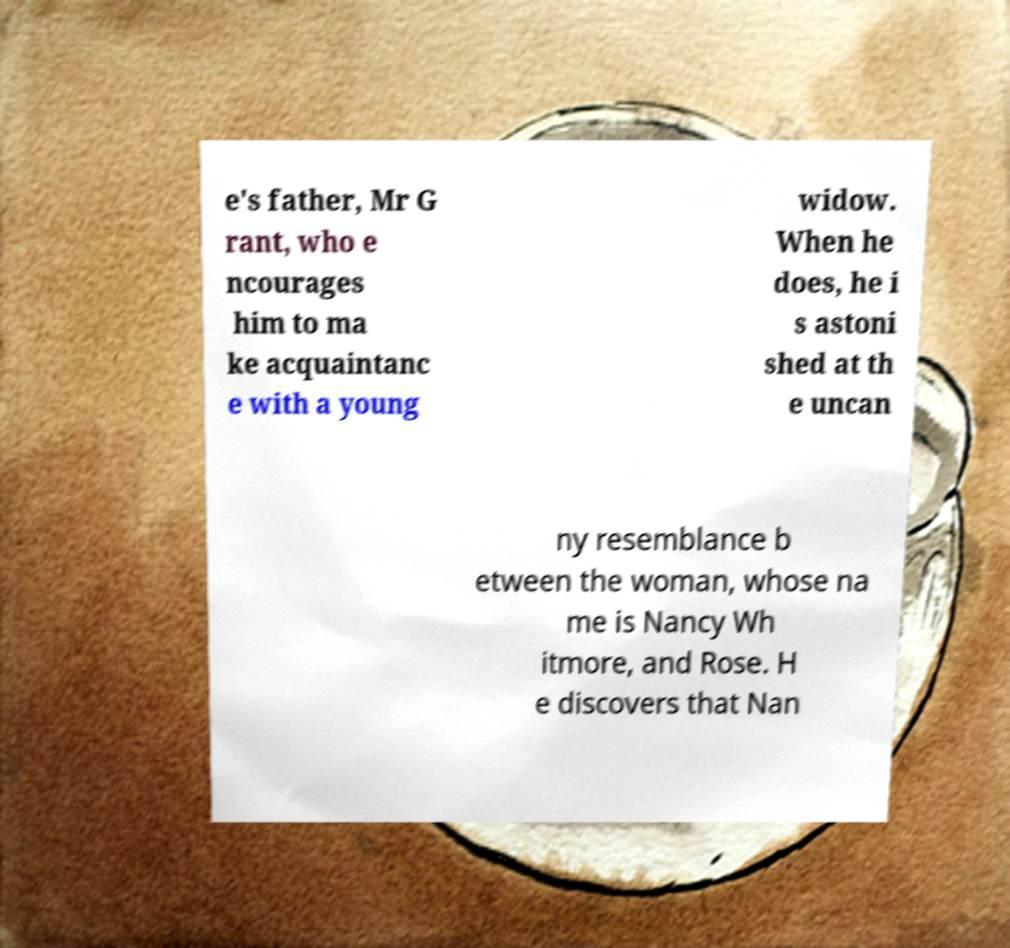Please read and relay the text visible in this image. What does it say? e's father, Mr G rant, who e ncourages him to ma ke acquaintanc e with a young widow. When he does, he i s astoni shed at th e uncan ny resemblance b etween the woman, whose na me is Nancy Wh itmore, and Rose. H e discovers that Nan 